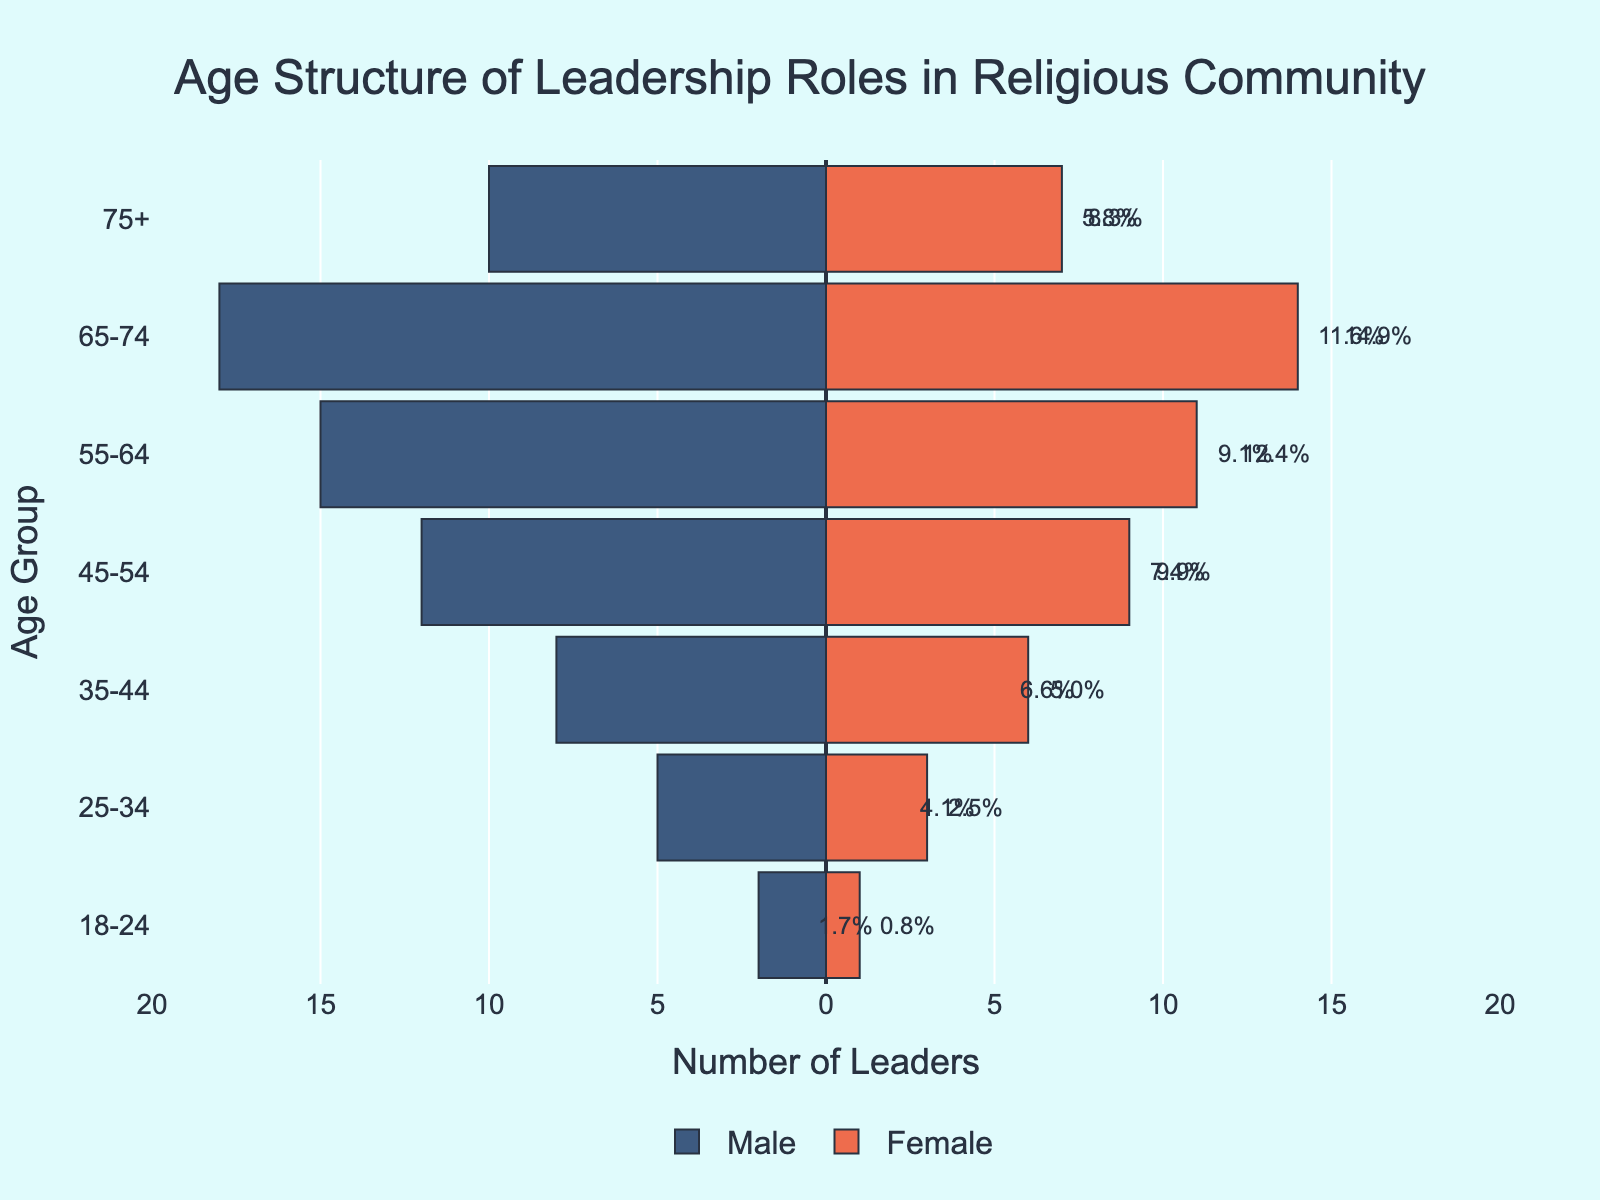Which age group has the highest number of male leaders? By looking at the bar chart, we see the largest negative bar representing males is in the 65-74 age group with 18 male leaders
Answer: 65-74 Which age group has more female than male leaders? By comparing the bars for each age group, we see there is no age group where the number of female leaders exceeds the number of male leaders
Answer: None What's the total number of leaders aged 55-64? The number of male leaders aged 55-64 is 15 and female leaders is 11. Combining these, we get 15 + 11 = 26
Answer: 26 In what age group do leaders represent the smallest percentage of the total? For each age group, look at the labels for the percentages. The 18-24 age group has the smallest with males representing 2/91 approx 2.2% and females 1/91 approx 1.1%, totalling about 3.3%
Answer: 18-24 How many more male leaders are there than female leaders in the 45-54 age group? The number of male leaders in the 45-54 age group is 12 and female leaders is 9. The difference is 12 - 9 = 3
Answer: 3 Which gender has a higher proportion of leaders aged 75 and above? Compared the lengths of the bars in the 75+ category. Males have 10 and females have 7; hence, males have a higher proportion
Answer: Male What age group has the greatest total number of leaders? Sum the male and female leaders for each age group, the age group 65-74 has the highest total with 18 males + 14 females = 32 leaders in total
Answer: 65-74 What is the ratio of male to female leaders in the 35-44 age group? The number of male leaders is 8 and the number of female leaders is 6. The ratio is 8:6, which simplifies to 4:3
Answer: 4:3 How many age groups have an equal number of male and female leaders? By comparing the counts for males and females across all age groups, there is no age group with equal numbers of male and female leaders
Answer: 0 What's the combined percentage of total leaders for the 55-64 and 65-74 age groups? Calculate percentages for each and add: (15+11)/91 + (18+14)/91, the combined percentage is approx 27.5% + 35.2% = 62.7%
Answer: 62.7% 